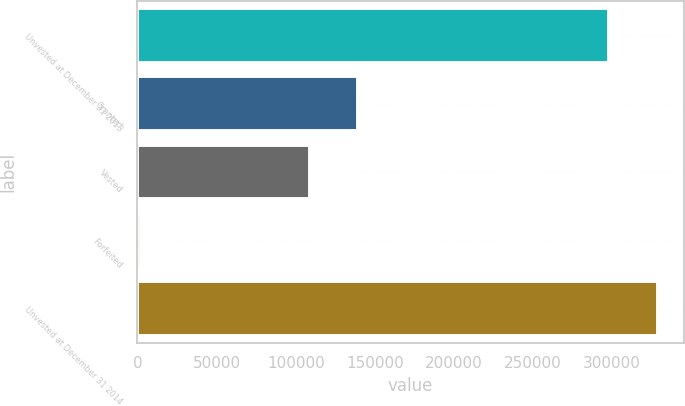<chart> <loc_0><loc_0><loc_500><loc_500><bar_chart><fcel>Unvested at December 31 2013<fcel>Granted<fcel>Vested<fcel>Forfeited<fcel>Unvested at December 31 2014<nl><fcel>298203<fcel>139376<fcel>108882<fcel>2030<fcel>328697<nl></chart> 